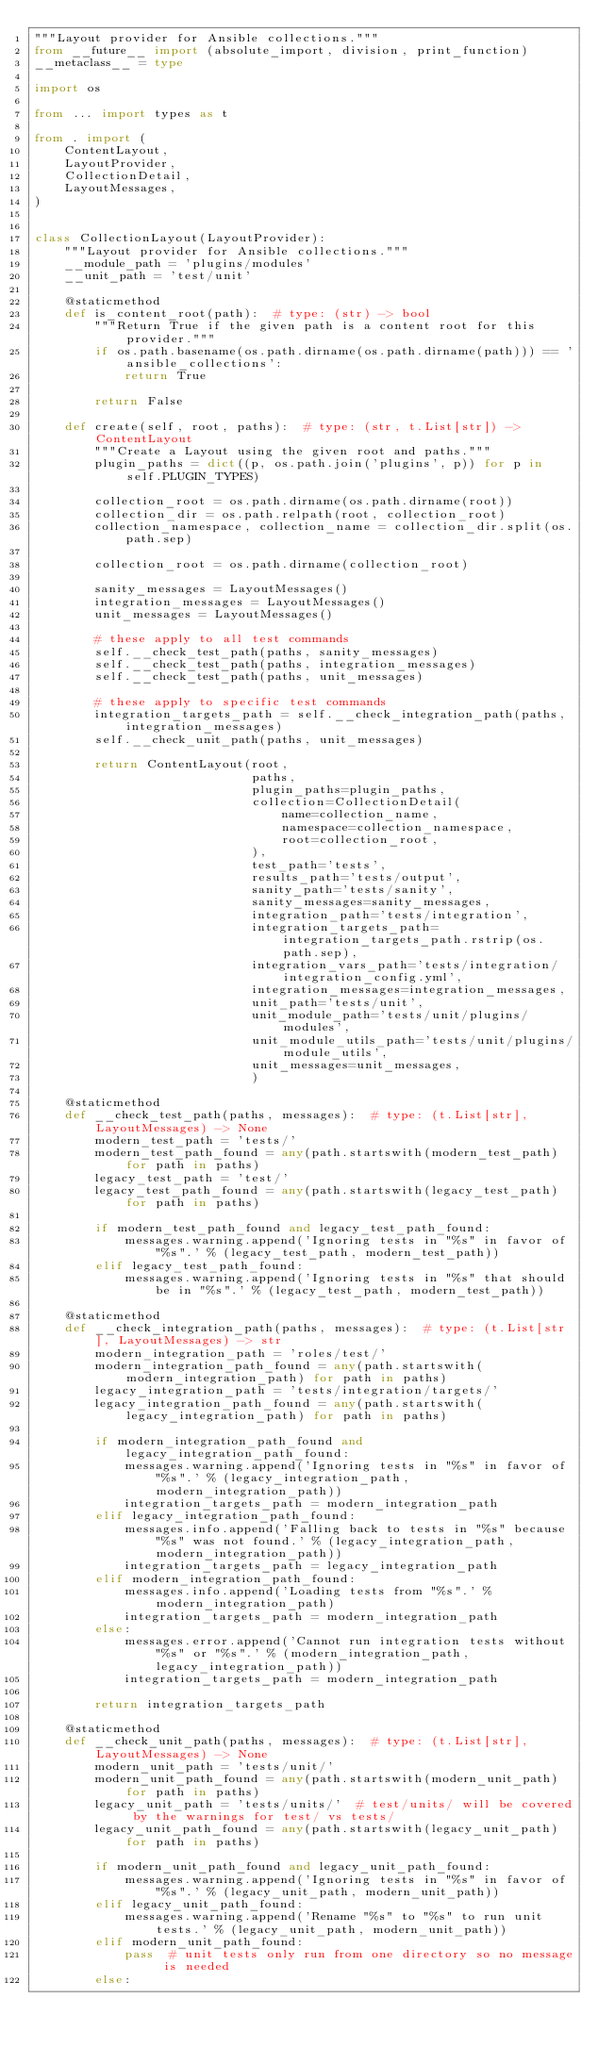Convert code to text. <code><loc_0><loc_0><loc_500><loc_500><_Python_>"""Layout provider for Ansible collections."""
from __future__ import (absolute_import, division, print_function)
__metaclass__ = type

import os

from ... import types as t

from . import (
    ContentLayout,
    LayoutProvider,
    CollectionDetail,
    LayoutMessages,
)


class CollectionLayout(LayoutProvider):
    """Layout provider for Ansible collections."""
    __module_path = 'plugins/modules'
    __unit_path = 'test/unit'

    @staticmethod
    def is_content_root(path):  # type: (str) -> bool
        """Return True if the given path is a content root for this provider."""
        if os.path.basename(os.path.dirname(os.path.dirname(path))) == 'ansible_collections':
            return True

        return False

    def create(self, root, paths):  # type: (str, t.List[str]) -> ContentLayout
        """Create a Layout using the given root and paths."""
        plugin_paths = dict((p, os.path.join('plugins', p)) for p in self.PLUGIN_TYPES)

        collection_root = os.path.dirname(os.path.dirname(root))
        collection_dir = os.path.relpath(root, collection_root)
        collection_namespace, collection_name = collection_dir.split(os.path.sep)

        collection_root = os.path.dirname(collection_root)

        sanity_messages = LayoutMessages()
        integration_messages = LayoutMessages()
        unit_messages = LayoutMessages()

        # these apply to all test commands
        self.__check_test_path(paths, sanity_messages)
        self.__check_test_path(paths, integration_messages)
        self.__check_test_path(paths, unit_messages)

        # these apply to specific test commands
        integration_targets_path = self.__check_integration_path(paths, integration_messages)
        self.__check_unit_path(paths, unit_messages)

        return ContentLayout(root,
                             paths,
                             plugin_paths=plugin_paths,
                             collection=CollectionDetail(
                                 name=collection_name,
                                 namespace=collection_namespace,
                                 root=collection_root,
                             ),
                             test_path='tests',
                             results_path='tests/output',
                             sanity_path='tests/sanity',
                             sanity_messages=sanity_messages,
                             integration_path='tests/integration',
                             integration_targets_path=integration_targets_path.rstrip(os.path.sep),
                             integration_vars_path='tests/integration/integration_config.yml',
                             integration_messages=integration_messages,
                             unit_path='tests/unit',
                             unit_module_path='tests/unit/plugins/modules',
                             unit_module_utils_path='tests/unit/plugins/module_utils',
                             unit_messages=unit_messages,
                             )

    @staticmethod
    def __check_test_path(paths, messages):  # type: (t.List[str], LayoutMessages) -> None
        modern_test_path = 'tests/'
        modern_test_path_found = any(path.startswith(modern_test_path) for path in paths)
        legacy_test_path = 'test/'
        legacy_test_path_found = any(path.startswith(legacy_test_path) for path in paths)

        if modern_test_path_found and legacy_test_path_found:
            messages.warning.append('Ignoring tests in "%s" in favor of "%s".' % (legacy_test_path, modern_test_path))
        elif legacy_test_path_found:
            messages.warning.append('Ignoring tests in "%s" that should be in "%s".' % (legacy_test_path, modern_test_path))

    @staticmethod
    def __check_integration_path(paths, messages):  # type: (t.List[str], LayoutMessages) -> str
        modern_integration_path = 'roles/test/'
        modern_integration_path_found = any(path.startswith(modern_integration_path) for path in paths)
        legacy_integration_path = 'tests/integration/targets/'
        legacy_integration_path_found = any(path.startswith(legacy_integration_path) for path in paths)

        if modern_integration_path_found and legacy_integration_path_found:
            messages.warning.append('Ignoring tests in "%s" in favor of "%s".' % (legacy_integration_path, modern_integration_path))
            integration_targets_path = modern_integration_path
        elif legacy_integration_path_found:
            messages.info.append('Falling back to tests in "%s" because "%s" was not found.' % (legacy_integration_path, modern_integration_path))
            integration_targets_path = legacy_integration_path
        elif modern_integration_path_found:
            messages.info.append('Loading tests from "%s".' % modern_integration_path)
            integration_targets_path = modern_integration_path
        else:
            messages.error.append('Cannot run integration tests without "%s" or "%s".' % (modern_integration_path, legacy_integration_path))
            integration_targets_path = modern_integration_path

        return integration_targets_path

    @staticmethod
    def __check_unit_path(paths, messages):  # type: (t.List[str], LayoutMessages) -> None
        modern_unit_path = 'tests/unit/'
        modern_unit_path_found = any(path.startswith(modern_unit_path) for path in paths)
        legacy_unit_path = 'tests/units/'  # test/units/ will be covered by the warnings for test/ vs tests/
        legacy_unit_path_found = any(path.startswith(legacy_unit_path) for path in paths)

        if modern_unit_path_found and legacy_unit_path_found:
            messages.warning.append('Ignoring tests in "%s" in favor of "%s".' % (legacy_unit_path, modern_unit_path))
        elif legacy_unit_path_found:
            messages.warning.append('Rename "%s" to "%s" to run unit tests.' % (legacy_unit_path, modern_unit_path))
        elif modern_unit_path_found:
            pass  # unit tests only run from one directory so no message is needed
        else:</code> 